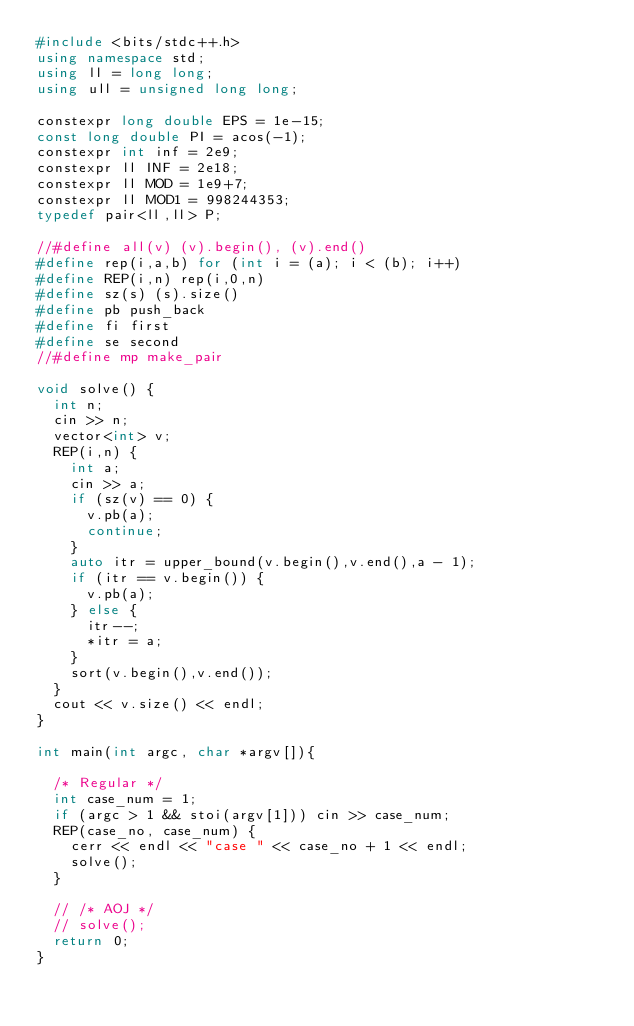Convert code to text. <code><loc_0><loc_0><loc_500><loc_500><_C++_>#include <bits/stdc++.h>
using namespace std;
using ll = long long;
using ull = unsigned long long;

constexpr long double EPS = 1e-15;
const long double PI = acos(-1);
constexpr int inf = 2e9;
constexpr ll INF = 2e18;
constexpr ll MOD = 1e9+7;
constexpr ll MOD1 = 998244353;
typedef pair<ll,ll> P;

//#define all(v) (v).begin(), (v).end()
#define rep(i,a,b) for (int i = (a); i < (b); i++)
#define REP(i,n) rep(i,0,n)
#define sz(s) (s).size()
#define pb push_back
#define fi first
#define se second
//#define mp make_pair

void solve() {
  int n;
  cin >> n;
  vector<int> v;
  REP(i,n) {
    int a;
    cin >> a;
    if (sz(v) == 0) {
      v.pb(a);
      continue;
    }
    auto itr = upper_bound(v.begin(),v.end(),a - 1);
    if (itr == v.begin()) {
      v.pb(a);
    } else {
      itr--;
      *itr = a;
    }
    sort(v.begin(),v.end());
  }
  cout << v.size() << endl;
}

int main(int argc, char *argv[]){

  /* Regular */
  int case_num = 1;
  if (argc > 1 && stoi(argv[1])) cin >> case_num;
  REP(case_no, case_num) {
    cerr << endl << "case " << case_no + 1 << endl;
    solve();
  }
  
  // /* AOJ */
  // solve();
  return 0;
}</code> 